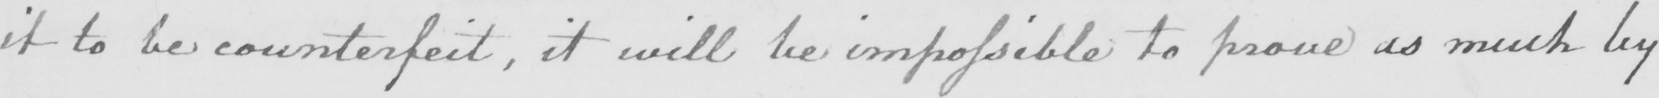What text is written in this handwritten line? it to be counterfeit , it will be impossible to prove as much by 